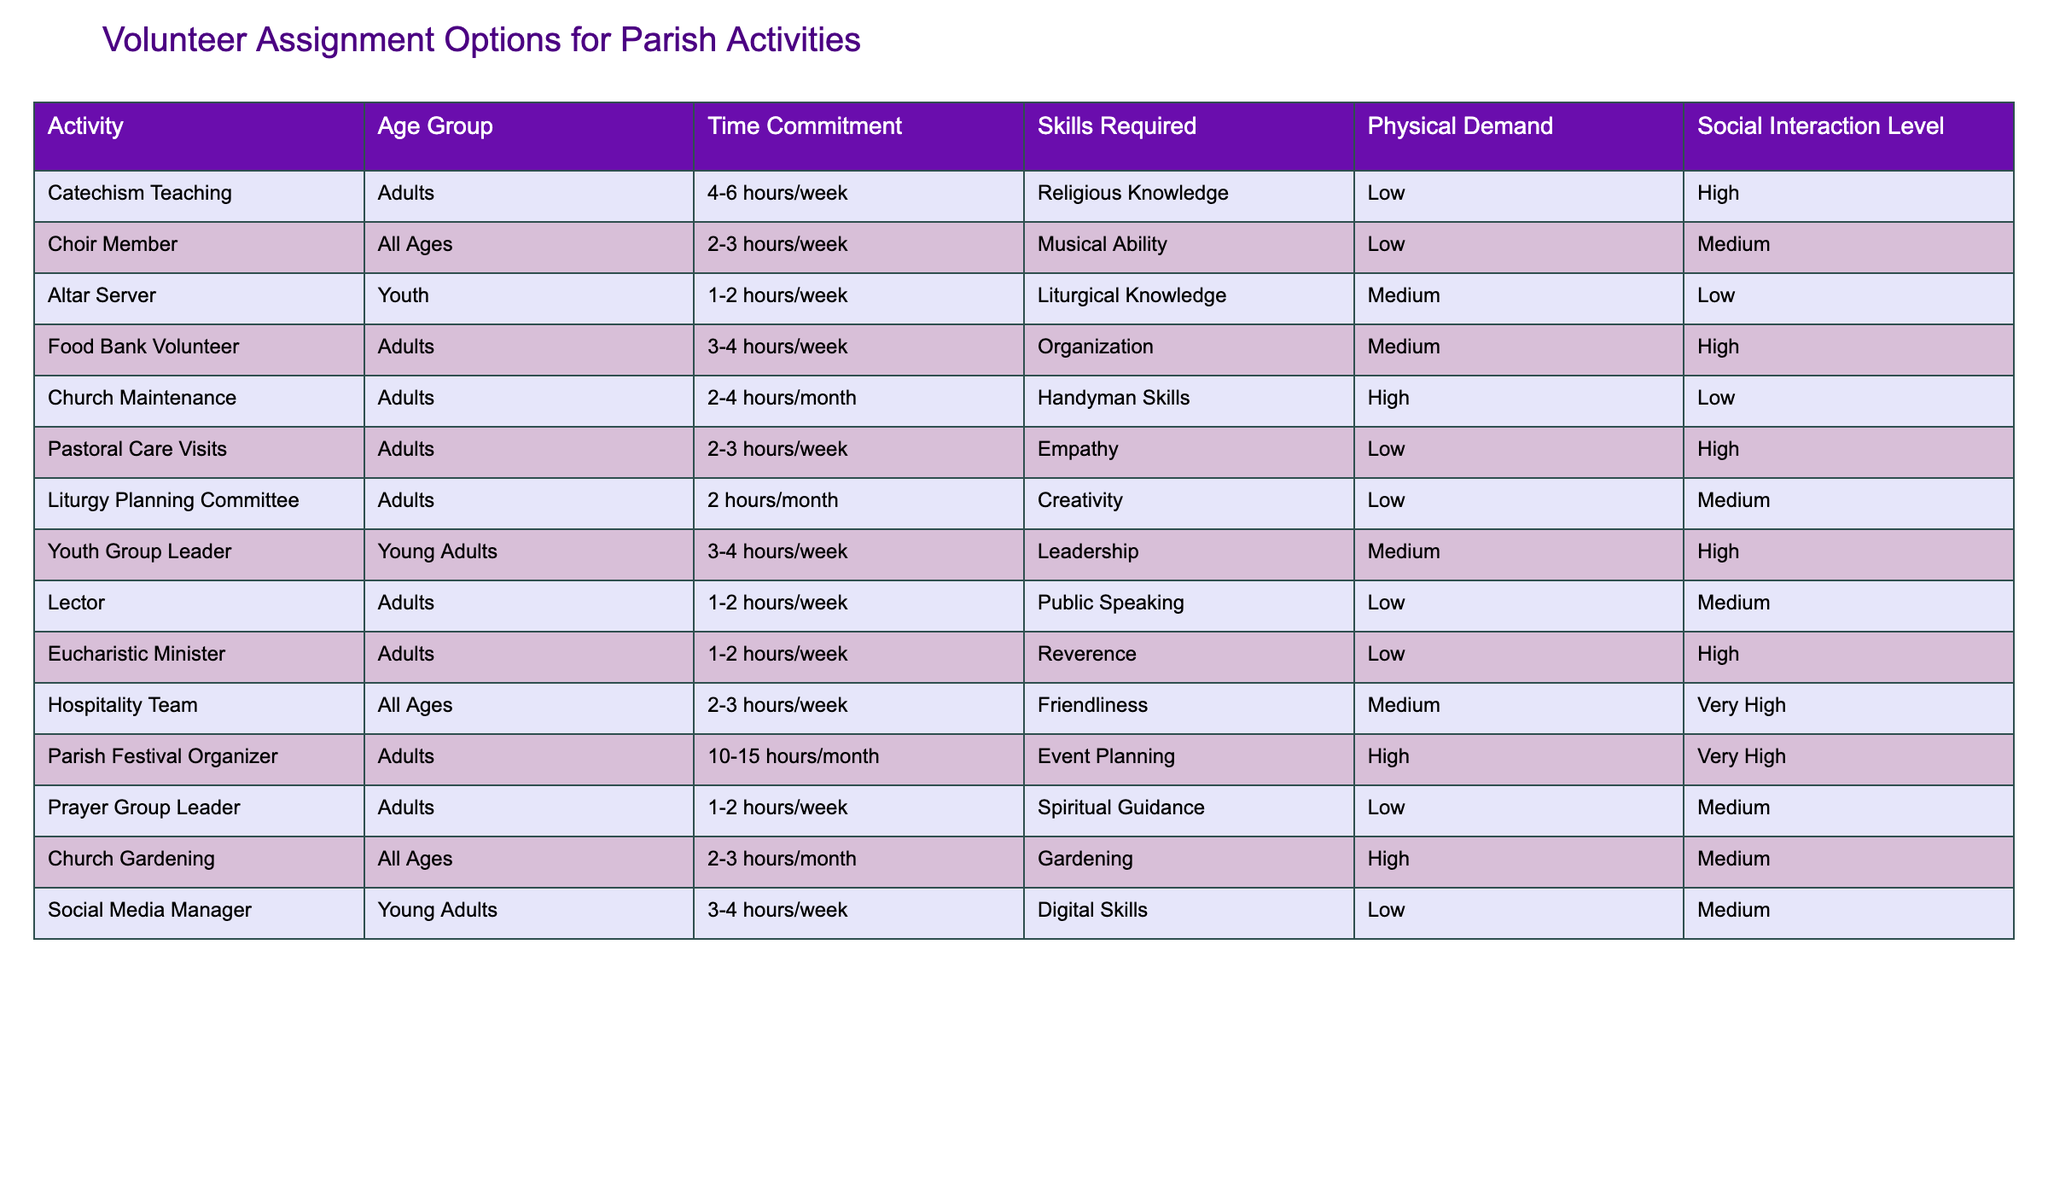What is the activity with the highest time commitment? The activity with the highest time commitment is the Parish Festival Organizer, which requires 10-15 hours/month.
Answer: Parish Festival Organizer How many activities have a high social interaction level? There are 4 activities with a high social interaction level: Catechism Teaching, Food Bank Volunteer, Pastoral Care Visits, and Hospitality Team.
Answer: 4 Are there any activities that require no specific skills? Yes, the Altar Server and Eucharistic Minister activities require no specific skills besides basic knowledge or reverence.
Answer: Yes Which age group has the highest number of volunteer activities? The Adults age group has 6 activities listed in the table: Catechism Teaching, Food Bank Volunteer, Pastoral Care Visits, Lector, Eucharistic Minister, and Parish Festival Organizer.
Answer: Adults What is the average time commitment for activities that require empathy? The only activity that requires empathy is Pastoral Care Visits, which needs 2-3 hours/week. Since there is only one data point, the average time commitment is simply that range, which is roughly 10-15 hours/month when converted.
Answer: 10-15 hours/month (average) Which volunteer assignment options require medium physical demand? The activities with medium physical demand are Food Bank Volunteer, Youth Group Leader, Church Gardening, and Altar Server.
Answer: Food Bank Volunteer, Youth Group Leader, Church Gardening, Altar Server Are all activities suitable for all age groups? No, not all activities are suitable for all age groups. For example, activities like Altar Server are specifically for youth and others are designated for adults or young adults.
Answer: No What is the total number of activities that require low social interaction? There are 4 activities that require low social interaction: Altar Server, Church Maintenance, Lector, and Prayer Group Leader.
Answer: 4 